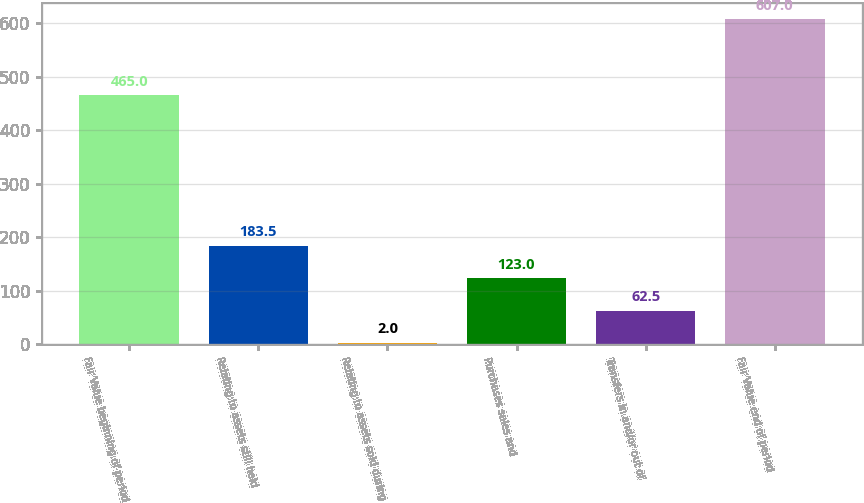Convert chart. <chart><loc_0><loc_0><loc_500><loc_500><bar_chart><fcel>Fair Value beginning of period<fcel>Relating to assets still held<fcel>Relating to assets sold during<fcel>Purchases sales and<fcel>Transfers in and/or out of<fcel>Fair Value end of period<nl><fcel>465<fcel>183.5<fcel>2<fcel>123<fcel>62.5<fcel>607<nl></chart> 